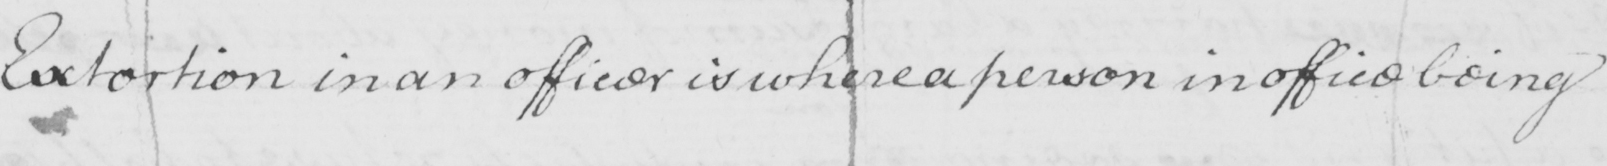Please provide the text content of this handwritten line. Extortion in an officer is where a person in office being 